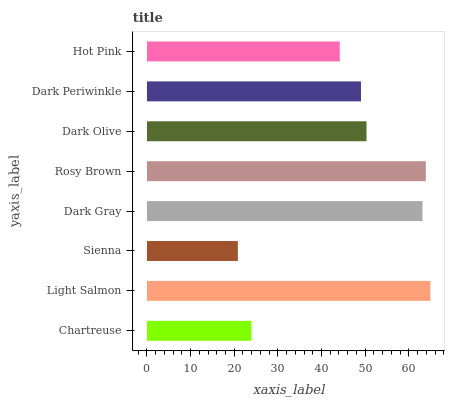Is Sienna the minimum?
Answer yes or no. Yes. Is Light Salmon the maximum?
Answer yes or no. Yes. Is Light Salmon the minimum?
Answer yes or no. No. Is Sienna the maximum?
Answer yes or no. No. Is Light Salmon greater than Sienna?
Answer yes or no. Yes. Is Sienna less than Light Salmon?
Answer yes or no. Yes. Is Sienna greater than Light Salmon?
Answer yes or no. No. Is Light Salmon less than Sienna?
Answer yes or no. No. Is Dark Olive the high median?
Answer yes or no. Yes. Is Dark Periwinkle the low median?
Answer yes or no. Yes. Is Light Salmon the high median?
Answer yes or no. No. Is Dark Gray the low median?
Answer yes or no. No. 